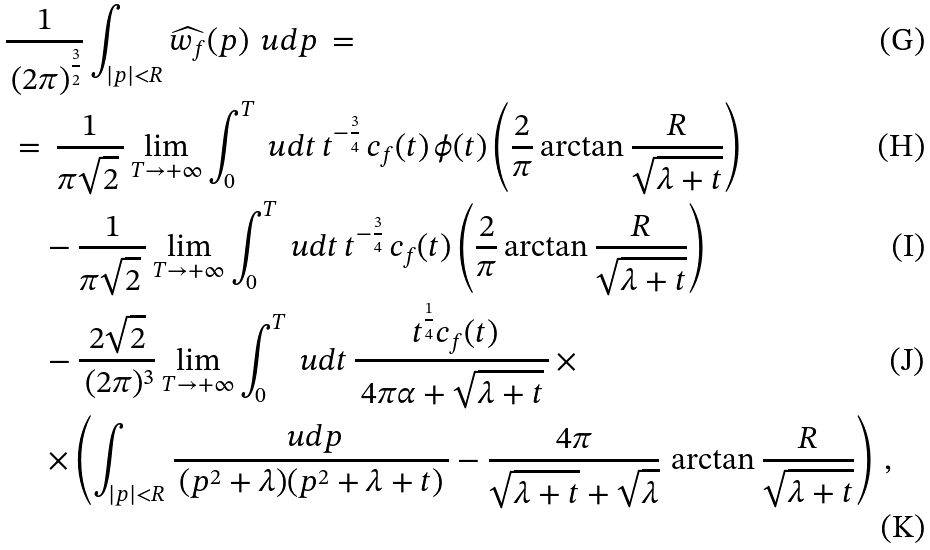<formula> <loc_0><loc_0><loc_500><loc_500>& \frac { 1 } { \, ( 2 \pi ) ^ { \frac { 3 } { 2 } } } \int _ { | p | < R } \widehat { w _ { f } } ( p ) \, \ u d p \, = \\ & \, = \, \frac { 1 } { \pi \sqrt { 2 } \, } \lim _ { T \to + \infty } \int _ { 0 } ^ { T } \ u d t \, t ^ { - \frac { 3 } { 4 } } \, c _ { f } ( t ) \, \phi ( t ) \left ( { \frac { 2 } { \pi } \arctan \frac { R } { \sqrt { \lambda + t } } } \right ) \\ & \, \quad - \frac { 1 } { \pi \sqrt { 2 } \, } \lim _ { T \to + \infty } \int _ { 0 } ^ { T } \ u d t \, t ^ { - \frac { 3 } { 4 } } \, c _ { f } ( t ) \left ( { \frac { 2 } { \pi } \arctan \frac { R } { \sqrt { \lambda + t } } } \right ) \\ & \, \quad - \frac { 2 \sqrt { 2 } } { \, ( 2 \pi ) ^ { 3 } } \lim _ { T \to + \infty } \int _ { 0 } ^ { T } \ u d t \, \frac { \, t ^ { \frac { 1 } { 4 } } c _ { f } ( t ) } { \, 4 \pi \alpha + \sqrt { \lambda + t } \, } \, \times \\ & \, \quad \times \left ( \int _ { | p | < R } \frac { \ u d p } { \, ( p ^ { 2 } + \lambda ) ( p ^ { 2 } + \lambda + t ) \, } - \frac { 4 \pi } { \sqrt { \lambda + t } + \sqrt { \lambda } } \, \arctan \frac { R } { \sqrt { \lambda + t } } \right ) \, ,</formula> 